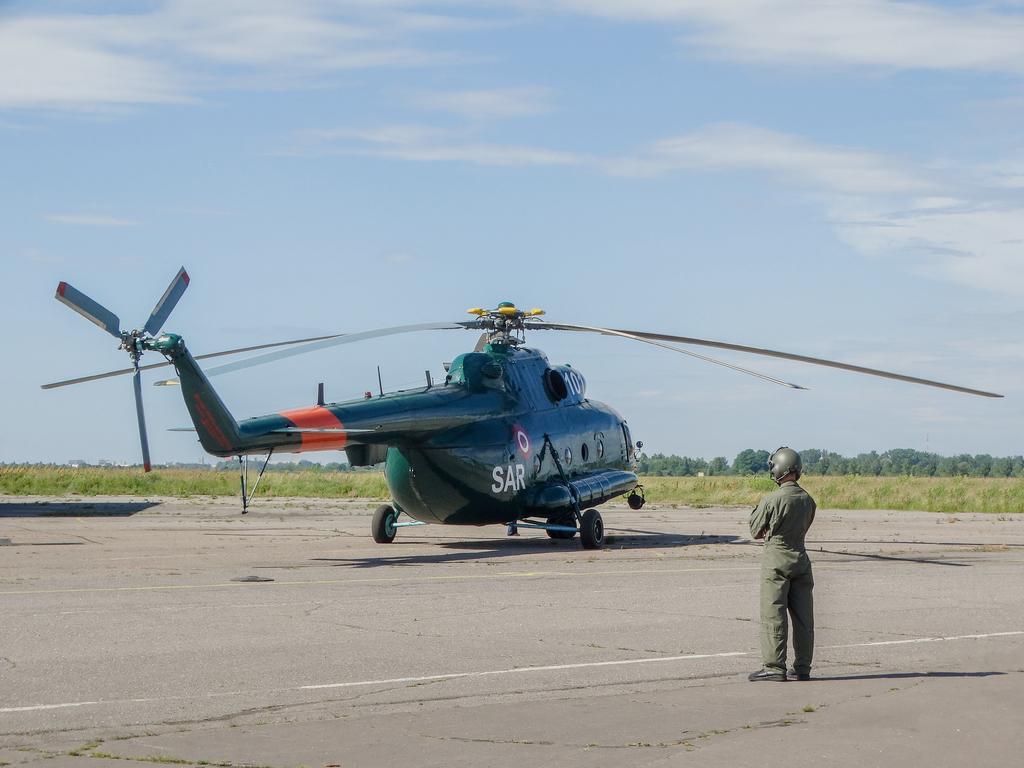Please provide a concise description of this image. In this picture we can see a helicopter and a person on the ground and in the background we can see trees, sky. 